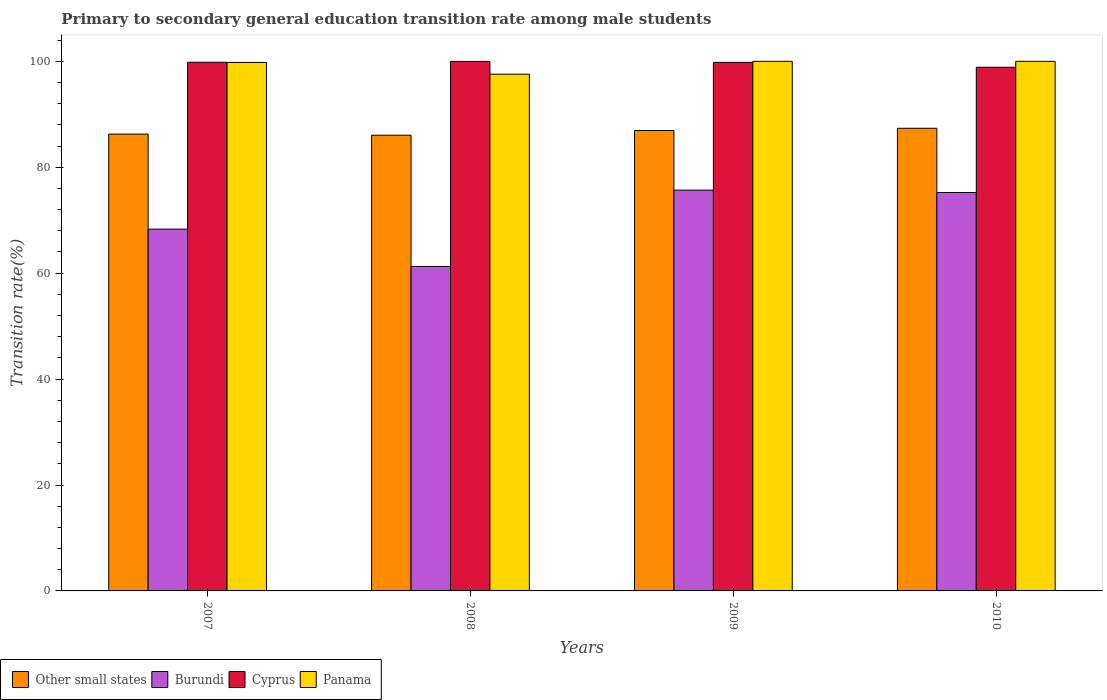How many different coloured bars are there?
Your response must be concise. 4. How many groups of bars are there?
Give a very brief answer. 4. Are the number of bars per tick equal to the number of legend labels?
Your answer should be very brief. Yes. Are the number of bars on each tick of the X-axis equal?
Your response must be concise. Yes. What is the label of the 1st group of bars from the left?
Offer a terse response. 2007. What is the transition rate in Burundi in 2010?
Give a very brief answer. 75.24. Across all years, what is the maximum transition rate in Cyprus?
Your response must be concise. 99.99. Across all years, what is the minimum transition rate in Cyprus?
Provide a short and direct response. 98.89. In which year was the transition rate in Burundi maximum?
Keep it short and to the point. 2009. In which year was the transition rate in Cyprus minimum?
Offer a very short reply. 2010. What is the total transition rate in Other small states in the graph?
Provide a short and direct response. 346.63. What is the difference between the transition rate in Cyprus in 2007 and that in 2009?
Provide a succinct answer. 0.02. What is the difference between the transition rate in Burundi in 2008 and the transition rate in Panama in 2007?
Provide a short and direct response. -38.51. What is the average transition rate in Cyprus per year?
Keep it short and to the point. 99.63. In the year 2008, what is the difference between the transition rate in Panama and transition rate in Cyprus?
Make the answer very short. -2.41. What is the ratio of the transition rate in Other small states in 2007 to that in 2008?
Provide a succinct answer. 1. What is the difference between the highest and the second highest transition rate in Burundi?
Ensure brevity in your answer.  0.45. What is the difference between the highest and the lowest transition rate in Cyprus?
Ensure brevity in your answer.  1.1. In how many years, is the transition rate in Cyprus greater than the average transition rate in Cyprus taken over all years?
Keep it short and to the point. 3. Is it the case that in every year, the sum of the transition rate in Panama and transition rate in Cyprus is greater than the sum of transition rate in Other small states and transition rate in Burundi?
Provide a succinct answer. No. What does the 4th bar from the left in 2008 represents?
Your answer should be compact. Panama. What does the 4th bar from the right in 2010 represents?
Ensure brevity in your answer.  Other small states. Are all the bars in the graph horizontal?
Offer a terse response. No. What is the difference between two consecutive major ticks on the Y-axis?
Give a very brief answer. 20. Where does the legend appear in the graph?
Ensure brevity in your answer.  Bottom left. What is the title of the graph?
Your answer should be compact. Primary to secondary general education transition rate among male students. Does "Bulgaria" appear as one of the legend labels in the graph?
Offer a very short reply. No. What is the label or title of the X-axis?
Offer a terse response. Years. What is the label or title of the Y-axis?
Make the answer very short. Transition rate(%). What is the Transition rate(%) of Other small states in 2007?
Keep it short and to the point. 86.26. What is the Transition rate(%) of Burundi in 2007?
Ensure brevity in your answer.  68.32. What is the Transition rate(%) of Cyprus in 2007?
Keep it short and to the point. 99.83. What is the Transition rate(%) in Panama in 2007?
Provide a succinct answer. 99.79. What is the Transition rate(%) in Other small states in 2008?
Provide a succinct answer. 86.06. What is the Transition rate(%) in Burundi in 2008?
Your response must be concise. 61.27. What is the Transition rate(%) in Cyprus in 2008?
Ensure brevity in your answer.  99.99. What is the Transition rate(%) of Panama in 2008?
Give a very brief answer. 97.58. What is the Transition rate(%) of Other small states in 2009?
Your answer should be compact. 86.94. What is the Transition rate(%) of Burundi in 2009?
Ensure brevity in your answer.  75.68. What is the Transition rate(%) in Cyprus in 2009?
Keep it short and to the point. 99.81. What is the Transition rate(%) of Other small states in 2010?
Keep it short and to the point. 87.36. What is the Transition rate(%) of Burundi in 2010?
Offer a very short reply. 75.24. What is the Transition rate(%) in Cyprus in 2010?
Provide a succinct answer. 98.89. What is the Transition rate(%) of Panama in 2010?
Keep it short and to the point. 100. Across all years, what is the maximum Transition rate(%) of Other small states?
Your answer should be compact. 87.36. Across all years, what is the maximum Transition rate(%) in Burundi?
Offer a terse response. 75.68. Across all years, what is the maximum Transition rate(%) of Cyprus?
Give a very brief answer. 99.99. Across all years, what is the minimum Transition rate(%) in Other small states?
Your answer should be very brief. 86.06. Across all years, what is the minimum Transition rate(%) of Burundi?
Give a very brief answer. 61.27. Across all years, what is the minimum Transition rate(%) in Cyprus?
Your answer should be very brief. 98.89. Across all years, what is the minimum Transition rate(%) in Panama?
Keep it short and to the point. 97.58. What is the total Transition rate(%) of Other small states in the graph?
Offer a terse response. 346.63. What is the total Transition rate(%) of Burundi in the graph?
Make the answer very short. 280.51. What is the total Transition rate(%) in Cyprus in the graph?
Your response must be concise. 398.51. What is the total Transition rate(%) of Panama in the graph?
Your response must be concise. 397.36. What is the difference between the Transition rate(%) of Other small states in 2007 and that in 2008?
Your answer should be very brief. 0.2. What is the difference between the Transition rate(%) of Burundi in 2007 and that in 2008?
Offer a terse response. 7.05. What is the difference between the Transition rate(%) in Cyprus in 2007 and that in 2008?
Provide a short and direct response. -0.15. What is the difference between the Transition rate(%) of Panama in 2007 and that in 2008?
Offer a terse response. 2.21. What is the difference between the Transition rate(%) in Other small states in 2007 and that in 2009?
Your answer should be compact. -0.68. What is the difference between the Transition rate(%) in Burundi in 2007 and that in 2009?
Offer a very short reply. -7.36. What is the difference between the Transition rate(%) of Cyprus in 2007 and that in 2009?
Your response must be concise. 0.02. What is the difference between the Transition rate(%) of Panama in 2007 and that in 2009?
Your response must be concise. -0.21. What is the difference between the Transition rate(%) of Other small states in 2007 and that in 2010?
Ensure brevity in your answer.  -1.1. What is the difference between the Transition rate(%) of Burundi in 2007 and that in 2010?
Provide a succinct answer. -6.92. What is the difference between the Transition rate(%) of Cyprus in 2007 and that in 2010?
Your answer should be compact. 0.95. What is the difference between the Transition rate(%) of Panama in 2007 and that in 2010?
Offer a terse response. -0.21. What is the difference between the Transition rate(%) of Other small states in 2008 and that in 2009?
Your response must be concise. -0.88. What is the difference between the Transition rate(%) in Burundi in 2008 and that in 2009?
Provide a succinct answer. -14.41. What is the difference between the Transition rate(%) of Cyprus in 2008 and that in 2009?
Your answer should be compact. 0.18. What is the difference between the Transition rate(%) of Panama in 2008 and that in 2009?
Provide a short and direct response. -2.42. What is the difference between the Transition rate(%) of Other small states in 2008 and that in 2010?
Keep it short and to the point. -1.3. What is the difference between the Transition rate(%) in Burundi in 2008 and that in 2010?
Make the answer very short. -13.96. What is the difference between the Transition rate(%) of Cyprus in 2008 and that in 2010?
Offer a very short reply. 1.1. What is the difference between the Transition rate(%) in Panama in 2008 and that in 2010?
Offer a terse response. -2.42. What is the difference between the Transition rate(%) of Other small states in 2009 and that in 2010?
Offer a very short reply. -0.42. What is the difference between the Transition rate(%) of Burundi in 2009 and that in 2010?
Your response must be concise. 0.45. What is the difference between the Transition rate(%) in Cyprus in 2009 and that in 2010?
Your answer should be very brief. 0.92. What is the difference between the Transition rate(%) of Panama in 2009 and that in 2010?
Ensure brevity in your answer.  0. What is the difference between the Transition rate(%) in Other small states in 2007 and the Transition rate(%) in Burundi in 2008?
Ensure brevity in your answer.  24.99. What is the difference between the Transition rate(%) of Other small states in 2007 and the Transition rate(%) of Cyprus in 2008?
Your answer should be very brief. -13.73. What is the difference between the Transition rate(%) of Other small states in 2007 and the Transition rate(%) of Panama in 2008?
Your answer should be very brief. -11.31. What is the difference between the Transition rate(%) in Burundi in 2007 and the Transition rate(%) in Cyprus in 2008?
Offer a very short reply. -31.67. What is the difference between the Transition rate(%) of Burundi in 2007 and the Transition rate(%) of Panama in 2008?
Give a very brief answer. -29.26. What is the difference between the Transition rate(%) of Cyprus in 2007 and the Transition rate(%) of Panama in 2008?
Provide a succinct answer. 2.26. What is the difference between the Transition rate(%) of Other small states in 2007 and the Transition rate(%) of Burundi in 2009?
Ensure brevity in your answer.  10.58. What is the difference between the Transition rate(%) of Other small states in 2007 and the Transition rate(%) of Cyprus in 2009?
Ensure brevity in your answer.  -13.55. What is the difference between the Transition rate(%) of Other small states in 2007 and the Transition rate(%) of Panama in 2009?
Make the answer very short. -13.74. What is the difference between the Transition rate(%) of Burundi in 2007 and the Transition rate(%) of Cyprus in 2009?
Keep it short and to the point. -31.49. What is the difference between the Transition rate(%) of Burundi in 2007 and the Transition rate(%) of Panama in 2009?
Offer a terse response. -31.68. What is the difference between the Transition rate(%) in Cyprus in 2007 and the Transition rate(%) in Panama in 2009?
Your answer should be compact. -0.17. What is the difference between the Transition rate(%) of Other small states in 2007 and the Transition rate(%) of Burundi in 2010?
Provide a succinct answer. 11.03. What is the difference between the Transition rate(%) of Other small states in 2007 and the Transition rate(%) of Cyprus in 2010?
Ensure brevity in your answer.  -12.62. What is the difference between the Transition rate(%) of Other small states in 2007 and the Transition rate(%) of Panama in 2010?
Offer a terse response. -13.74. What is the difference between the Transition rate(%) in Burundi in 2007 and the Transition rate(%) in Cyprus in 2010?
Your answer should be compact. -30.57. What is the difference between the Transition rate(%) of Burundi in 2007 and the Transition rate(%) of Panama in 2010?
Offer a terse response. -31.68. What is the difference between the Transition rate(%) in Cyprus in 2007 and the Transition rate(%) in Panama in 2010?
Provide a short and direct response. -0.17. What is the difference between the Transition rate(%) of Other small states in 2008 and the Transition rate(%) of Burundi in 2009?
Provide a succinct answer. 10.38. What is the difference between the Transition rate(%) in Other small states in 2008 and the Transition rate(%) in Cyprus in 2009?
Your answer should be very brief. -13.75. What is the difference between the Transition rate(%) of Other small states in 2008 and the Transition rate(%) of Panama in 2009?
Provide a succinct answer. -13.94. What is the difference between the Transition rate(%) in Burundi in 2008 and the Transition rate(%) in Cyprus in 2009?
Keep it short and to the point. -38.53. What is the difference between the Transition rate(%) of Burundi in 2008 and the Transition rate(%) of Panama in 2009?
Your response must be concise. -38.73. What is the difference between the Transition rate(%) in Cyprus in 2008 and the Transition rate(%) in Panama in 2009?
Your response must be concise. -0.01. What is the difference between the Transition rate(%) in Other small states in 2008 and the Transition rate(%) in Burundi in 2010?
Provide a succinct answer. 10.82. What is the difference between the Transition rate(%) in Other small states in 2008 and the Transition rate(%) in Cyprus in 2010?
Your answer should be compact. -12.83. What is the difference between the Transition rate(%) in Other small states in 2008 and the Transition rate(%) in Panama in 2010?
Keep it short and to the point. -13.94. What is the difference between the Transition rate(%) in Burundi in 2008 and the Transition rate(%) in Cyprus in 2010?
Offer a terse response. -37.61. What is the difference between the Transition rate(%) in Burundi in 2008 and the Transition rate(%) in Panama in 2010?
Your answer should be compact. -38.73. What is the difference between the Transition rate(%) of Cyprus in 2008 and the Transition rate(%) of Panama in 2010?
Provide a short and direct response. -0.01. What is the difference between the Transition rate(%) of Other small states in 2009 and the Transition rate(%) of Burundi in 2010?
Provide a short and direct response. 11.71. What is the difference between the Transition rate(%) of Other small states in 2009 and the Transition rate(%) of Cyprus in 2010?
Provide a succinct answer. -11.95. What is the difference between the Transition rate(%) in Other small states in 2009 and the Transition rate(%) in Panama in 2010?
Keep it short and to the point. -13.06. What is the difference between the Transition rate(%) of Burundi in 2009 and the Transition rate(%) of Cyprus in 2010?
Keep it short and to the point. -23.2. What is the difference between the Transition rate(%) in Burundi in 2009 and the Transition rate(%) in Panama in 2010?
Your answer should be very brief. -24.32. What is the difference between the Transition rate(%) of Cyprus in 2009 and the Transition rate(%) of Panama in 2010?
Provide a succinct answer. -0.19. What is the average Transition rate(%) of Other small states per year?
Your answer should be very brief. 86.66. What is the average Transition rate(%) of Burundi per year?
Keep it short and to the point. 70.13. What is the average Transition rate(%) in Cyprus per year?
Your answer should be very brief. 99.63. What is the average Transition rate(%) in Panama per year?
Give a very brief answer. 99.34. In the year 2007, what is the difference between the Transition rate(%) of Other small states and Transition rate(%) of Burundi?
Your answer should be very brief. 17.94. In the year 2007, what is the difference between the Transition rate(%) of Other small states and Transition rate(%) of Cyprus?
Provide a short and direct response. -13.57. In the year 2007, what is the difference between the Transition rate(%) in Other small states and Transition rate(%) in Panama?
Your answer should be very brief. -13.53. In the year 2007, what is the difference between the Transition rate(%) in Burundi and Transition rate(%) in Cyprus?
Your response must be concise. -31.51. In the year 2007, what is the difference between the Transition rate(%) in Burundi and Transition rate(%) in Panama?
Make the answer very short. -31.47. In the year 2007, what is the difference between the Transition rate(%) of Cyprus and Transition rate(%) of Panama?
Offer a very short reply. 0.05. In the year 2008, what is the difference between the Transition rate(%) of Other small states and Transition rate(%) of Burundi?
Your response must be concise. 24.79. In the year 2008, what is the difference between the Transition rate(%) in Other small states and Transition rate(%) in Cyprus?
Give a very brief answer. -13.93. In the year 2008, what is the difference between the Transition rate(%) of Other small states and Transition rate(%) of Panama?
Offer a very short reply. -11.52. In the year 2008, what is the difference between the Transition rate(%) of Burundi and Transition rate(%) of Cyprus?
Provide a succinct answer. -38.71. In the year 2008, what is the difference between the Transition rate(%) in Burundi and Transition rate(%) in Panama?
Provide a succinct answer. -36.3. In the year 2008, what is the difference between the Transition rate(%) of Cyprus and Transition rate(%) of Panama?
Your response must be concise. 2.41. In the year 2009, what is the difference between the Transition rate(%) in Other small states and Transition rate(%) in Burundi?
Offer a terse response. 11.26. In the year 2009, what is the difference between the Transition rate(%) in Other small states and Transition rate(%) in Cyprus?
Your answer should be very brief. -12.87. In the year 2009, what is the difference between the Transition rate(%) of Other small states and Transition rate(%) of Panama?
Your response must be concise. -13.06. In the year 2009, what is the difference between the Transition rate(%) in Burundi and Transition rate(%) in Cyprus?
Keep it short and to the point. -24.13. In the year 2009, what is the difference between the Transition rate(%) of Burundi and Transition rate(%) of Panama?
Your answer should be compact. -24.32. In the year 2009, what is the difference between the Transition rate(%) of Cyprus and Transition rate(%) of Panama?
Your answer should be compact. -0.19. In the year 2010, what is the difference between the Transition rate(%) of Other small states and Transition rate(%) of Burundi?
Your answer should be compact. 12.13. In the year 2010, what is the difference between the Transition rate(%) in Other small states and Transition rate(%) in Cyprus?
Provide a short and direct response. -11.52. In the year 2010, what is the difference between the Transition rate(%) of Other small states and Transition rate(%) of Panama?
Offer a terse response. -12.64. In the year 2010, what is the difference between the Transition rate(%) of Burundi and Transition rate(%) of Cyprus?
Make the answer very short. -23.65. In the year 2010, what is the difference between the Transition rate(%) of Burundi and Transition rate(%) of Panama?
Offer a terse response. -24.76. In the year 2010, what is the difference between the Transition rate(%) of Cyprus and Transition rate(%) of Panama?
Make the answer very short. -1.11. What is the ratio of the Transition rate(%) of Burundi in 2007 to that in 2008?
Provide a short and direct response. 1.11. What is the ratio of the Transition rate(%) in Panama in 2007 to that in 2008?
Make the answer very short. 1.02. What is the ratio of the Transition rate(%) in Burundi in 2007 to that in 2009?
Give a very brief answer. 0.9. What is the ratio of the Transition rate(%) in Panama in 2007 to that in 2009?
Ensure brevity in your answer.  1. What is the ratio of the Transition rate(%) in Other small states in 2007 to that in 2010?
Your answer should be very brief. 0.99. What is the ratio of the Transition rate(%) of Burundi in 2007 to that in 2010?
Offer a very short reply. 0.91. What is the ratio of the Transition rate(%) in Cyprus in 2007 to that in 2010?
Your answer should be very brief. 1.01. What is the ratio of the Transition rate(%) in Burundi in 2008 to that in 2009?
Your response must be concise. 0.81. What is the ratio of the Transition rate(%) in Panama in 2008 to that in 2009?
Offer a terse response. 0.98. What is the ratio of the Transition rate(%) in Other small states in 2008 to that in 2010?
Your response must be concise. 0.99. What is the ratio of the Transition rate(%) of Burundi in 2008 to that in 2010?
Provide a succinct answer. 0.81. What is the ratio of the Transition rate(%) in Cyprus in 2008 to that in 2010?
Offer a very short reply. 1.01. What is the ratio of the Transition rate(%) of Panama in 2008 to that in 2010?
Ensure brevity in your answer.  0.98. What is the ratio of the Transition rate(%) in Other small states in 2009 to that in 2010?
Provide a succinct answer. 1. What is the ratio of the Transition rate(%) in Burundi in 2009 to that in 2010?
Your response must be concise. 1.01. What is the ratio of the Transition rate(%) in Cyprus in 2009 to that in 2010?
Give a very brief answer. 1.01. What is the difference between the highest and the second highest Transition rate(%) of Other small states?
Offer a terse response. 0.42. What is the difference between the highest and the second highest Transition rate(%) in Burundi?
Offer a very short reply. 0.45. What is the difference between the highest and the second highest Transition rate(%) of Cyprus?
Your answer should be compact. 0.15. What is the difference between the highest and the second highest Transition rate(%) of Panama?
Make the answer very short. 0. What is the difference between the highest and the lowest Transition rate(%) of Other small states?
Offer a terse response. 1.3. What is the difference between the highest and the lowest Transition rate(%) in Burundi?
Offer a very short reply. 14.41. What is the difference between the highest and the lowest Transition rate(%) in Cyprus?
Keep it short and to the point. 1.1. What is the difference between the highest and the lowest Transition rate(%) of Panama?
Offer a very short reply. 2.42. 